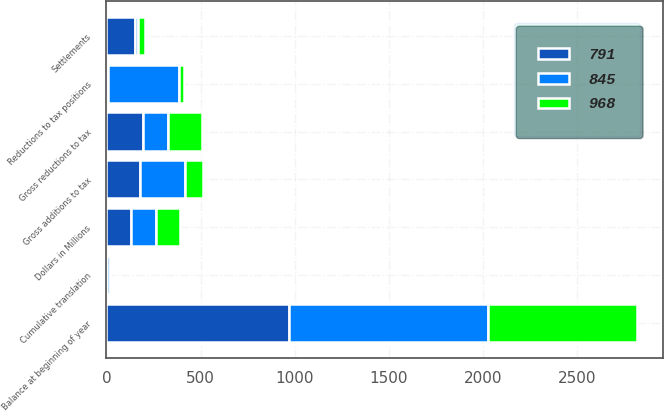Convert chart to OTSL. <chart><loc_0><loc_0><loc_500><loc_500><stacked_bar_chart><ecel><fcel>Dollars in Millions<fcel>Balance at beginning of year<fcel>Gross additions to tax<fcel>Gross reductions to tax<fcel>Settlements<fcel>Reductions to tax positions<fcel>Cumulative translation<nl><fcel>791<fcel>131<fcel>968<fcel>177<fcel>196<fcel>153<fcel>7<fcel>1<nl><fcel>968<fcel>131<fcel>791<fcel>97<fcel>180<fcel>37<fcel>29<fcel>2<nl><fcel>845<fcel>131<fcel>1058<fcel>238<fcel>131<fcel>17<fcel>378<fcel>18<nl></chart> 